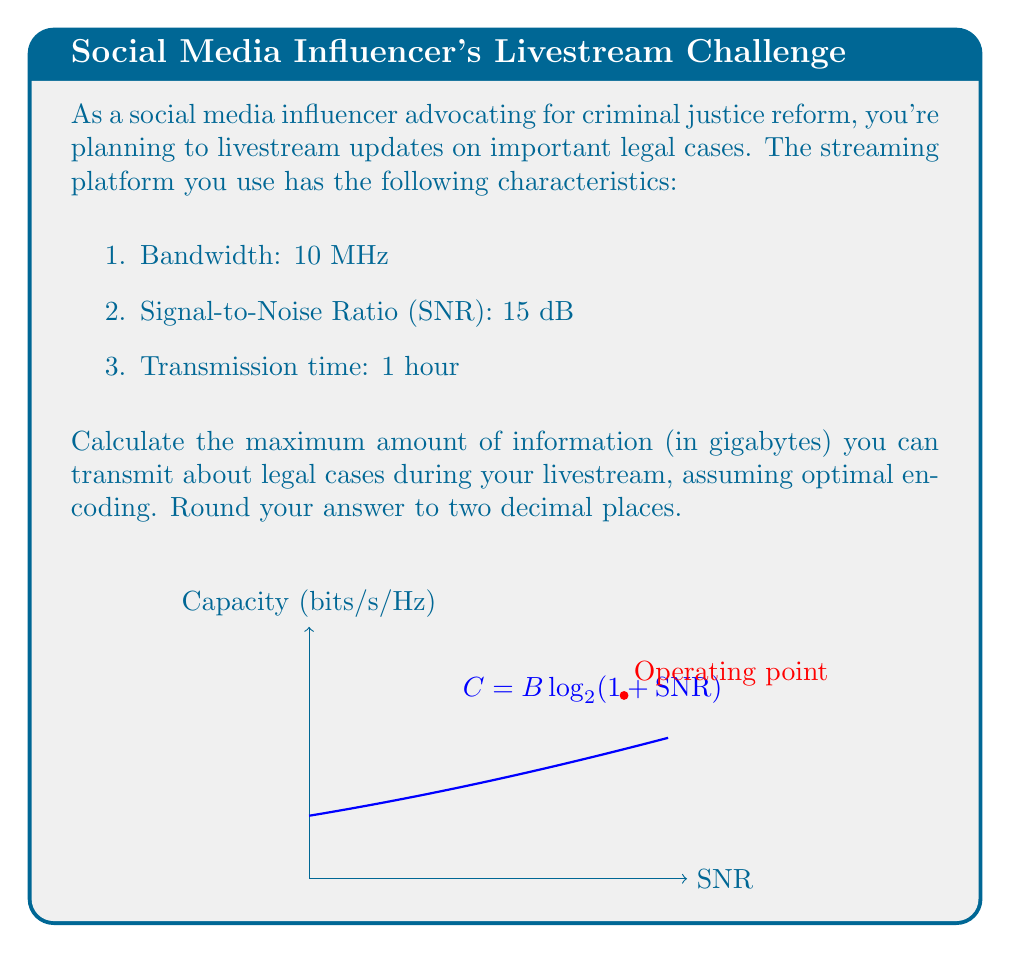Help me with this question. To solve this problem, we'll use the Shannon-Hartley theorem and follow these steps:

1) First, convert the SNR from dB to a linear scale:
   $\text{SNR}_{\text{linear}} = 10^{\frac{\text{SNR}_{\text{dB}}}{10}} = 10^{\frac{15}{10}} = 31.6228$

2) Calculate the channel capacity using the Shannon-Hartley theorem:
   $C = B \log_2(1 + \text{SNR})$
   Where $C$ is the channel capacity in bits/second, and $B$ is the bandwidth in Hz.

   $C = 10 \times 10^6 \times \log_2(1 + 31.6228)$
   $C = 10 \times 10^6 \times 5.0444$
   $C = 50,444,000$ bits/second

3) Calculate the total number of bits that can be transmitted in 1 hour:
   Total bits = $C \times \text{time in seconds}$
   $= 50,444,000 \times (60 \times 60)$
   $= 181,598,400,000$ bits

4) Convert bits to bytes:
   Bytes = $\frac{181,598,400,000}{8} = 22,699,800,000$ bytes

5) Convert bytes to gigabytes:
   GB = $\frac{22,699,800,000}{10^9} = 22.6998$ GB

6) Round to two decimal places:
   $22.70$ GB

This represents the maximum amount of information you can transmit about legal cases during your one-hour livestream, assuming optimal encoding and utilization of the channel capacity.
Answer: 22.70 GB 